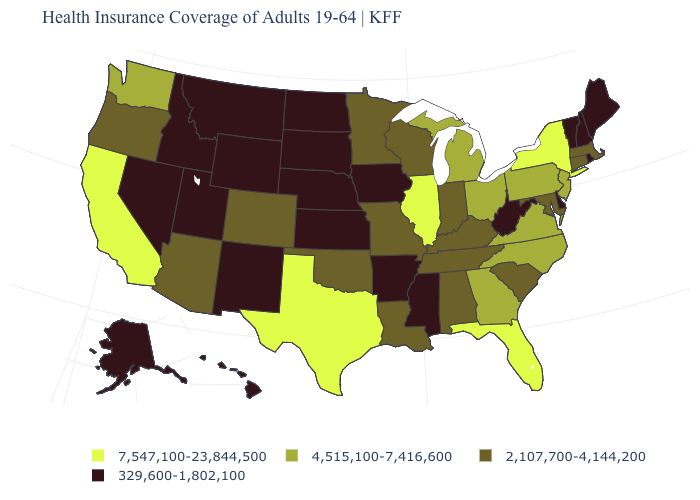Name the states that have a value in the range 329,600-1,802,100?
Short answer required. Alaska, Arkansas, Delaware, Hawaii, Idaho, Iowa, Kansas, Maine, Mississippi, Montana, Nebraska, Nevada, New Hampshire, New Mexico, North Dakota, Rhode Island, South Dakota, Utah, Vermont, West Virginia, Wyoming. Name the states that have a value in the range 2,107,700-4,144,200?
Write a very short answer. Alabama, Arizona, Colorado, Connecticut, Indiana, Kentucky, Louisiana, Maryland, Massachusetts, Minnesota, Missouri, Oklahoma, Oregon, South Carolina, Tennessee, Wisconsin. What is the lowest value in the USA?
Write a very short answer. 329,600-1,802,100. Does the map have missing data?
Keep it brief. No. Which states hav the highest value in the West?
Answer briefly. California. Which states have the highest value in the USA?
Short answer required. California, Florida, Illinois, New York, Texas. Does Colorado have the lowest value in the West?
Keep it brief. No. Which states have the lowest value in the West?
Concise answer only. Alaska, Hawaii, Idaho, Montana, Nevada, New Mexico, Utah, Wyoming. Name the states that have a value in the range 4,515,100-7,416,600?
Keep it brief. Georgia, Michigan, New Jersey, North Carolina, Ohio, Pennsylvania, Virginia, Washington. Name the states that have a value in the range 4,515,100-7,416,600?
Give a very brief answer. Georgia, Michigan, New Jersey, North Carolina, Ohio, Pennsylvania, Virginia, Washington. What is the highest value in the USA?
Concise answer only. 7,547,100-23,844,500. Name the states that have a value in the range 329,600-1,802,100?
Quick response, please. Alaska, Arkansas, Delaware, Hawaii, Idaho, Iowa, Kansas, Maine, Mississippi, Montana, Nebraska, Nevada, New Hampshire, New Mexico, North Dakota, Rhode Island, South Dakota, Utah, Vermont, West Virginia, Wyoming. Which states hav the highest value in the West?
Concise answer only. California. Does Alabama have the highest value in the South?
Answer briefly. No. Name the states that have a value in the range 7,547,100-23,844,500?
Write a very short answer. California, Florida, Illinois, New York, Texas. 